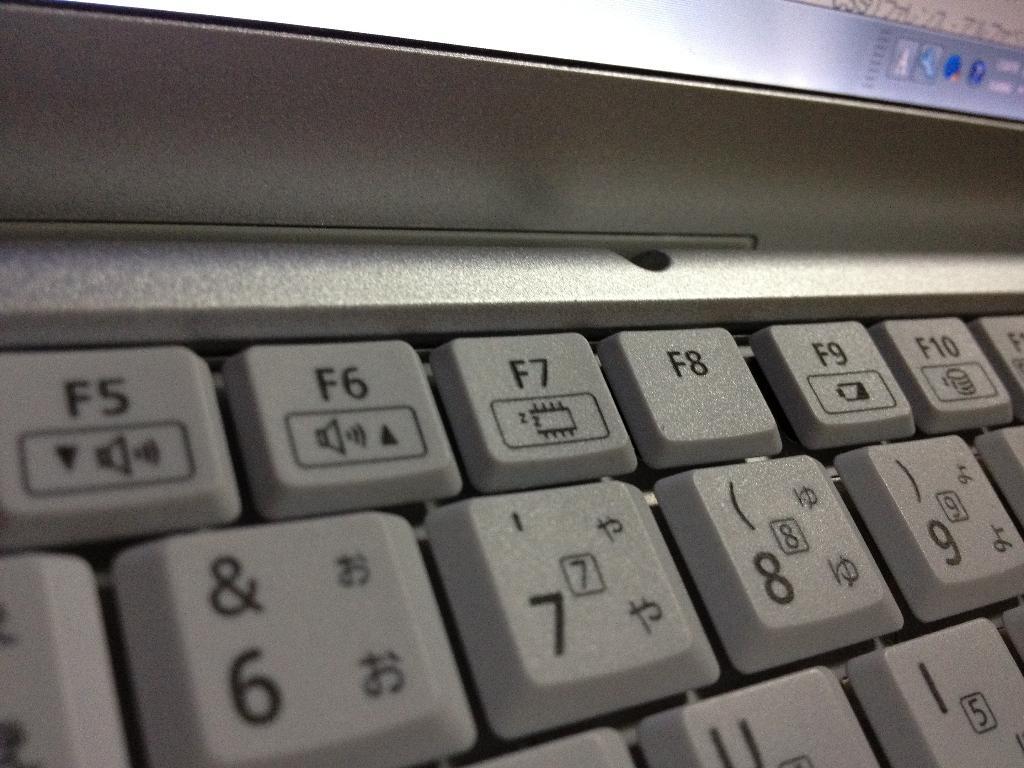How would you summarize this image in a sentence or two? In this image there are buttons on the keyboard which are visible. 